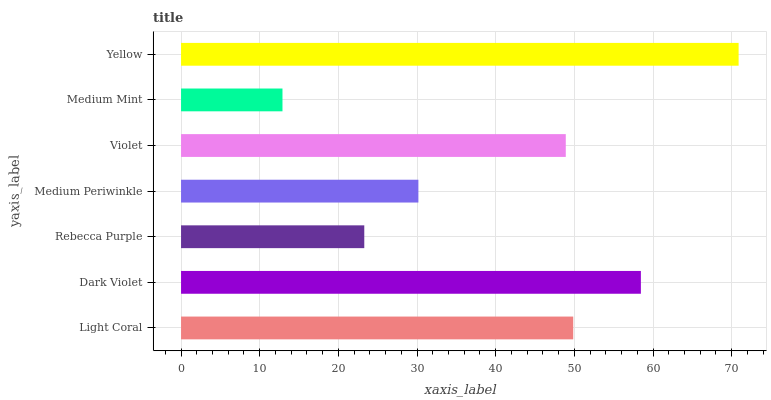Is Medium Mint the minimum?
Answer yes or no. Yes. Is Yellow the maximum?
Answer yes or no. Yes. Is Dark Violet the minimum?
Answer yes or no. No. Is Dark Violet the maximum?
Answer yes or no. No. Is Dark Violet greater than Light Coral?
Answer yes or no. Yes. Is Light Coral less than Dark Violet?
Answer yes or no. Yes. Is Light Coral greater than Dark Violet?
Answer yes or no. No. Is Dark Violet less than Light Coral?
Answer yes or no. No. Is Violet the high median?
Answer yes or no. Yes. Is Violet the low median?
Answer yes or no. Yes. Is Light Coral the high median?
Answer yes or no. No. Is Light Coral the low median?
Answer yes or no. No. 